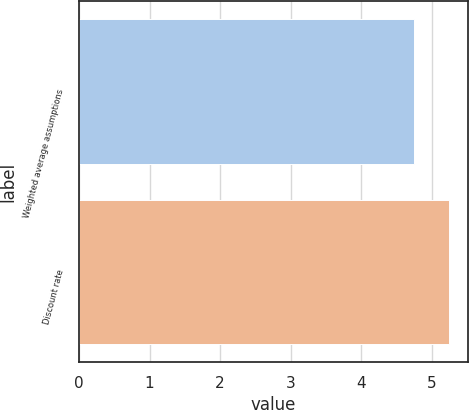Convert chart to OTSL. <chart><loc_0><loc_0><loc_500><loc_500><bar_chart><fcel>Weighted average assumptions<fcel>Discount rate<nl><fcel>4.75<fcel>5.25<nl></chart> 